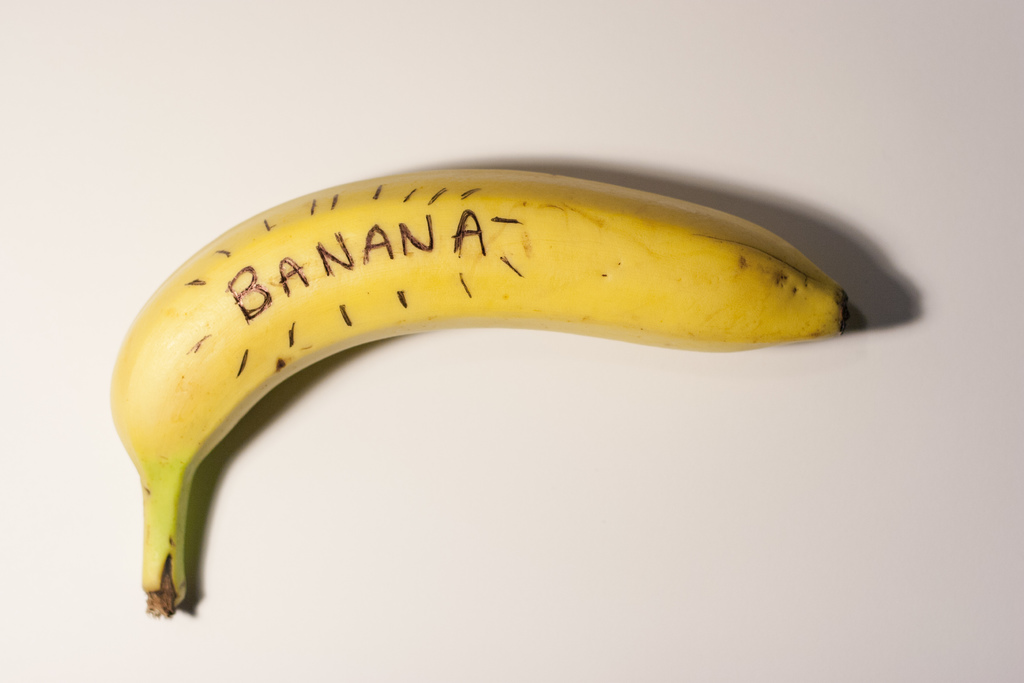Explain the visual content of the image in great detail. The image captures a ripe banana lying against a stark white background, emphasizing its vibrant yellow hue. The banana curves gracefully, with its tapered end and a healthy greenish stem suggesting recent detachment from the bunch. The skin, mostly smooth, hosts sporadic black speckles often seen on bananas as they ripen. Intriguingly, the word 'BANANA' is etched onto the fruit’s surface in bold, black strokes, surrounded by fine, hair-like markings that seem hand-drawn. This labeling is unusual and whimsical, presenting a blend of natural fruit anatomy with a human touch of labeling, perhaps as a playful or educational gesture. 